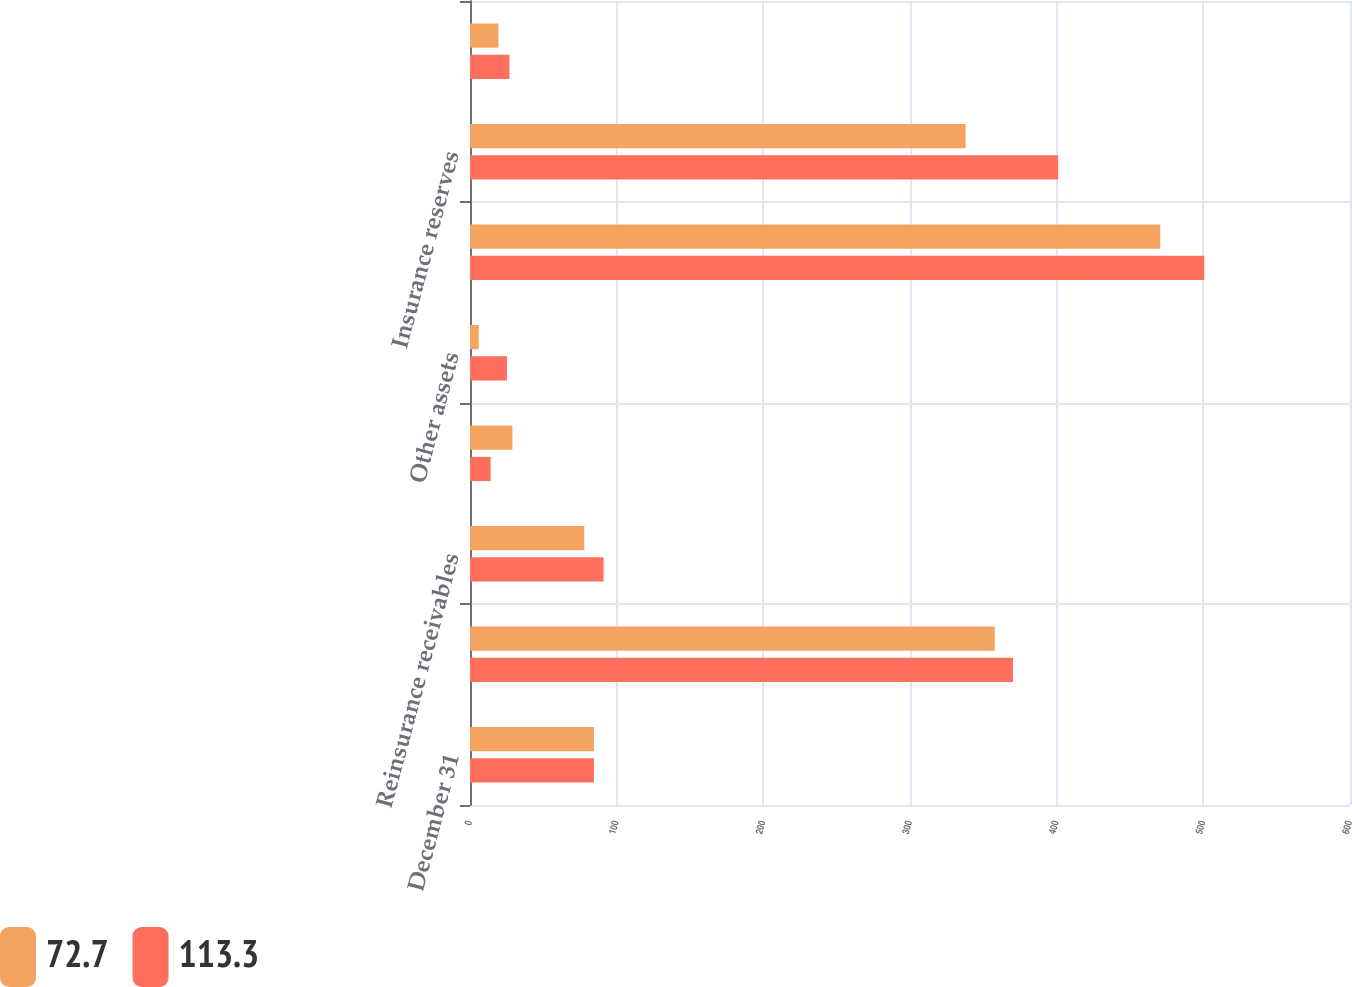<chart> <loc_0><loc_0><loc_500><loc_500><stacked_bar_chart><ecel><fcel>December 31<fcel>Investments<fcel>Reinsurance receivables<fcel>Cash<fcel>Other assets<fcel>Total assets<fcel>Insurance reserves<fcel>Other liabilities<nl><fcel>72.7<fcel>84.5<fcel>357.8<fcel>77.9<fcel>28.9<fcel>6<fcel>470.6<fcel>337.9<fcel>19.4<nl><fcel>113.3<fcel>84.5<fcel>370.2<fcel>91.1<fcel>14.1<fcel>25.2<fcel>500.6<fcel>401<fcel>26.9<nl></chart> 